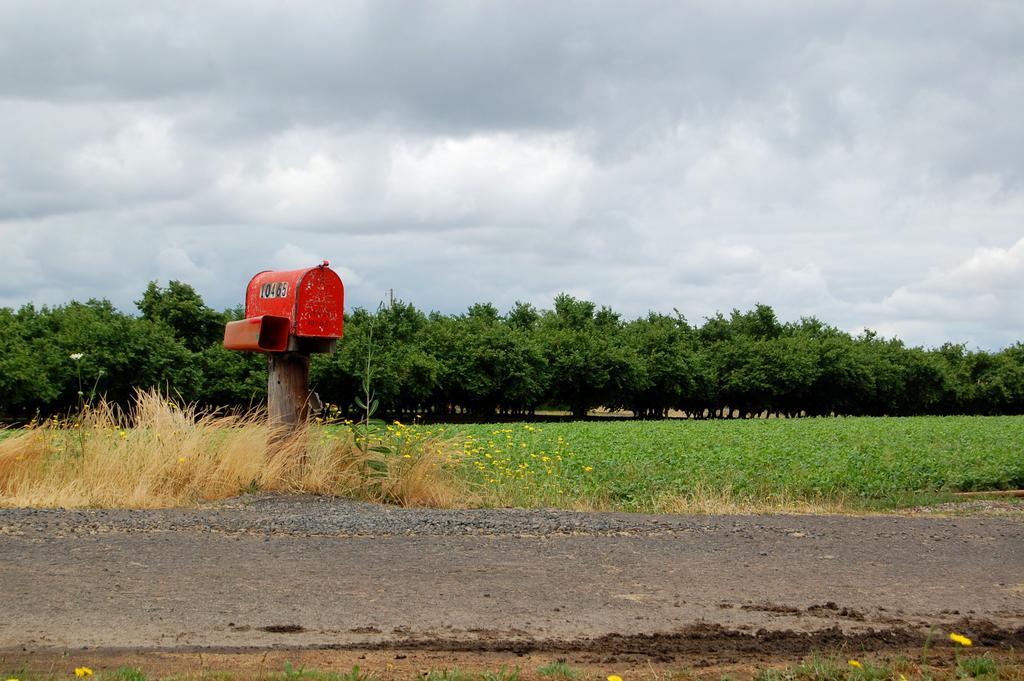In one or two sentences, can you explain what this image depicts? In the image in the center we can see one post office,which is in red color. In the background we can see the sky,clouds,trees,grass,plants,flowers and road. 